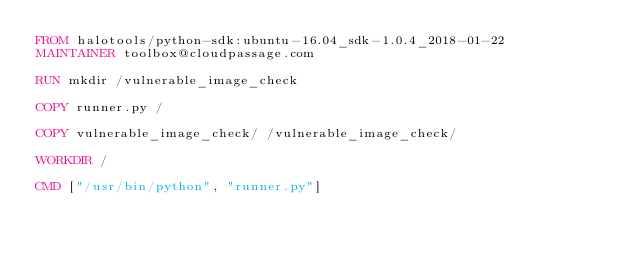<code> <loc_0><loc_0><loc_500><loc_500><_Dockerfile_>FROM halotools/python-sdk:ubuntu-16.04_sdk-1.0.4_2018-01-22
MAINTAINER toolbox@cloudpassage.com

RUN mkdir /vulnerable_image_check

COPY runner.py /

COPY vulnerable_image_check/ /vulnerable_image_check/

WORKDIR /

CMD ["/usr/bin/python", "runner.py"]
</code> 